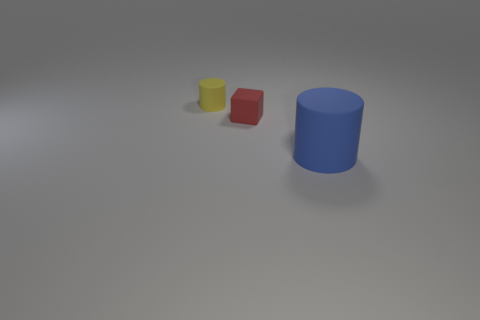Add 2 small cyan rubber blocks. How many objects exist? 5 Subtract all cylinders. How many objects are left? 1 Add 1 blocks. How many blocks are left? 2 Add 1 green matte cylinders. How many green matte cylinders exist? 1 Subtract 0 green cylinders. How many objects are left? 3 Subtract all green blocks. Subtract all big things. How many objects are left? 2 